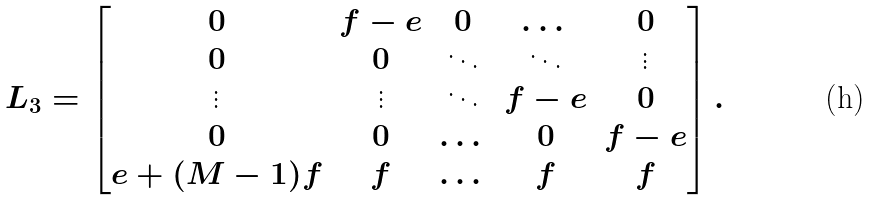Convert formula to latex. <formula><loc_0><loc_0><loc_500><loc_500>L _ { 3 } = \begin{bmatrix} 0 & f - e & 0 & \dots & 0 \\ 0 & 0 & \ddots & \ddots & \vdots \\ \vdots & \vdots & \ddots & f - e & 0 \\ 0 & 0 & \dots & 0 & f - e \\ e + ( M - 1 ) f & f & \dots & f & f \end{bmatrix} .</formula> 